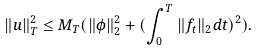Convert formula to latex. <formula><loc_0><loc_0><loc_500><loc_500>\| u \| _ { T } ^ { 2 } \leq M _ { T } ( \| \phi \| _ { 2 } ^ { 2 } + ( \int _ { 0 } ^ { T } \| f _ { t } \| _ { 2 } d t ) ^ { 2 } ) .</formula> 